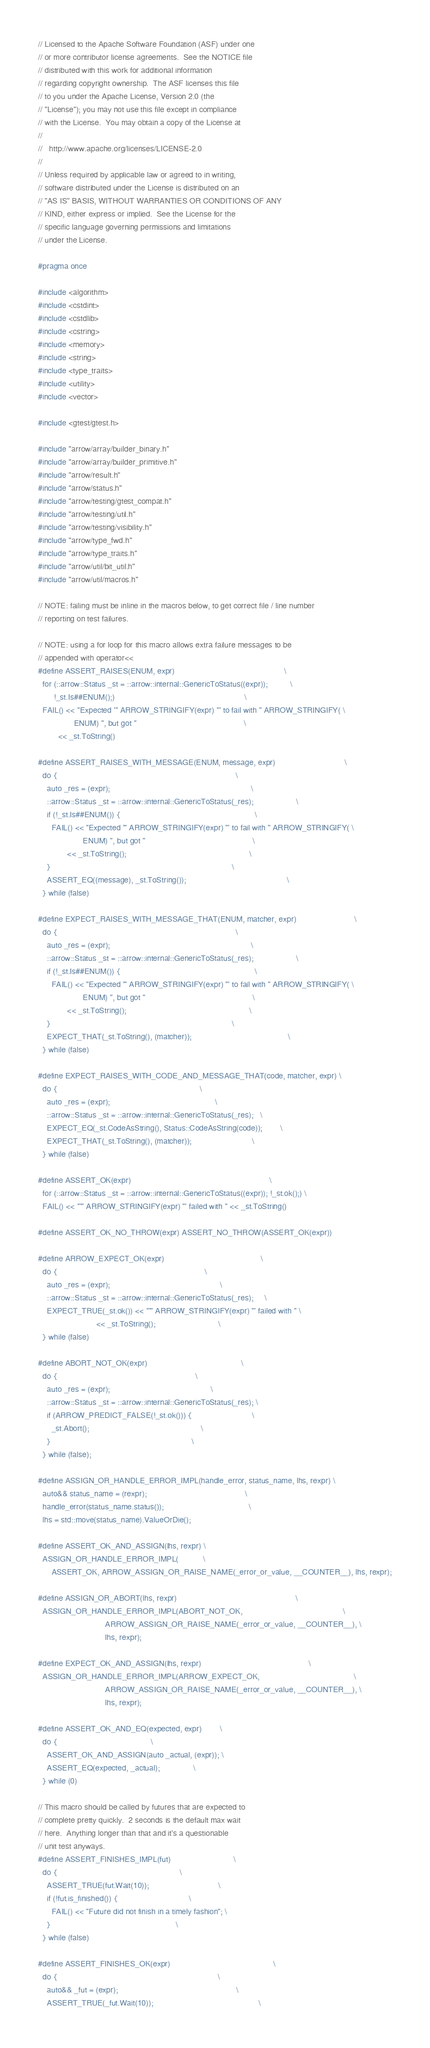<code> <loc_0><loc_0><loc_500><loc_500><_C_>// Licensed to the Apache Software Foundation (ASF) under one
// or more contributor license agreements.  See the NOTICE file
// distributed with this work for additional information
// regarding copyright ownership.  The ASF licenses this file
// to you under the Apache License, Version 2.0 (the
// "License"); you may not use this file except in compliance
// with the License.  You may obtain a copy of the License at
//
//   http://www.apache.org/licenses/LICENSE-2.0
//
// Unless required by applicable law or agreed to in writing,
// software distributed under the License is distributed on an
// "AS IS" BASIS, WITHOUT WARRANTIES OR CONDITIONS OF ANY
// KIND, either express or implied.  See the License for the
// specific language governing permissions and limitations
// under the License.

#pragma once

#include <algorithm>
#include <cstdint>
#include <cstdlib>
#include <cstring>
#include <memory>
#include <string>
#include <type_traits>
#include <utility>
#include <vector>

#include <gtest/gtest.h>

#include "arrow/array/builder_binary.h"
#include "arrow/array/builder_primitive.h"
#include "arrow/result.h"
#include "arrow/status.h"
#include "arrow/testing/gtest_compat.h"
#include "arrow/testing/util.h"
#include "arrow/testing/visibility.h"
#include "arrow/type_fwd.h"
#include "arrow/type_traits.h"
#include "arrow/util/bit_util.h"
#include "arrow/util/macros.h"

// NOTE: failing must be inline in the macros below, to get correct file / line number
// reporting on test failures.

// NOTE: using a for loop for this macro allows extra failure messages to be
// appended with operator<<
#define ASSERT_RAISES(ENUM, expr)                                                 \
  for (::arrow::Status _st = ::arrow::internal::GenericToStatus((expr));          \
       !_st.Is##ENUM();)                                                          \
  FAIL() << "Expected '" ARROW_STRINGIFY(expr) "' to fail with " ARROW_STRINGIFY( \
                ENUM) ", but got "                                                \
         << _st.ToString()

#define ASSERT_RAISES_WITH_MESSAGE(ENUM, message, expr)                               \
  do {                                                                                \
    auto _res = (expr);                                                               \
    ::arrow::Status _st = ::arrow::internal::GenericToStatus(_res);                   \
    if (!_st.Is##ENUM()) {                                                            \
      FAIL() << "Expected '" ARROW_STRINGIFY(expr) "' to fail with " ARROW_STRINGIFY( \
                    ENUM) ", but got "                                                \
             << _st.ToString();                                                       \
    }                                                                                 \
    ASSERT_EQ((message), _st.ToString());                                             \
  } while (false)

#define EXPECT_RAISES_WITH_MESSAGE_THAT(ENUM, matcher, expr)                          \
  do {                                                                                \
    auto _res = (expr);                                                               \
    ::arrow::Status _st = ::arrow::internal::GenericToStatus(_res);                   \
    if (!_st.Is##ENUM()) {                                                            \
      FAIL() << "Expected '" ARROW_STRINGIFY(expr) "' to fail with " ARROW_STRINGIFY( \
                    ENUM) ", but got "                                                \
             << _st.ToString();                                                       \
    }                                                                                 \
    EXPECT_THAT(_st.ToString(), (matcher));                                           \
  } while (false)

#define EXPECT_RAISES_WITH_CODE_AND_MESSAGE_THAT(code, matcher, expr) \
  do {                                                                \
    auto _res = (expr);                                               \
    ::arrow::Status _st = ::arrow::internal::GenericToStatus(_res);   \
    EXPECT_EQ(_st.CodeAsString(), Status::CodeAsString(code));        \
    EXPECT_THAT(_st.ToString(), (matcher));                           \
  } while (false)

#define ASSERT_OK(expr)                                                              \
  for (::arrow::Status _st = ::arrow::internal::GenericToStatus((expr)); !_st.ok();) \
  FAIL() << "'" ARROW_STRINGIFY(expr) "' failed with " << _st.ToString()

#define ASSERT_OK_NO_THROW(expr) ASSERT_NO_THROW(ASSERT_OK(expr))

#define ARROW_EXPECT_OK(expr)                                           \
  do {                                                                  \
    auto _res = (expr);                                                 \
    ::arrow::Status _st = ::arrow::internal::GenericToStatus(_res);     \
    EXPECT_TRUE(_st.ok()) << "'" ARROW_STRINGIFY(expr) "' failed with " \
                          << _st.ToString();                            \
  } while (false)

#define ABORT_NOT_OK(expr)                                          \
  do {                                                              \
    auto _res = (expr);                                             \
    ::arrow::Status _st = ::arrow::internal::GenericToStatus(_res); \
    if (ARROW_PREDICT_FALSE(!_st.ok())) {                           \
      _st.Abort();                                                  \
    }                                                               \
  } while (false);

#define ASSIGN_OR_HANDLE_ERROR_IMPL(handle_error, status_name, lhs, rexpr) \
  auto&& status_name = (rexpr);                                            \
  handle_error(status_name.status());                                      \
  lhs = std::move(status_name).ValueOrDie();

#define ASSERT_OK_AND_ASSIGN(lhs, rexpr) \
  ASSIGN_OR_HANDLE_ERROR_IMPL(           \
      ASSERT_OK, ARROW_ASSIGN_OR_RAISE_NAME(_error_or_value, __COUNTER__), lhs, rexpr);

#define ASSIGN_OR_ABORT(lhs, rexpr)                                                     \
  ASSIGN_OR_HANDLE_ERROR_IMPL(ABORT_NOT_OK,                                             \
                              ARROW_ASSIGN_OR_RAISE_NAME(_error_or_value, __COUNTER__), \
                              lhs, rexpr);

#define EXPECT_OK_AND_ASSIGN(lhs, rexpr)                                                \
  ASSIGN_OR_HANDLE_ERROR_IMPL(ARROW_EXPECT_OK,                                          \
                              ARROW_ASSIGN_OR_RAISE_NAME(_error_or_value, __COUNTER__), \
                              lhs, rexpr);

#define ASSERT_OK_AND_EQ(expected, expr)        \
  do {                                          \
    ASSERT_OK_AND_ASSIGN(auto _actual, (expr)); \
    ASSERT_EQ(expected, _actual);               \
  } while (0)

// This macro should be called by futures that are expected to
// complete pretty quickly.  2 seconds is the default max wait
// here.  Anything longer than that and it's a questionable
// unit test anyways.
#define ASSERT_FINISHES_IMPL(fut)                            \
  do {                                                       \
    ASSERT_TRUE(fut.Wait(10));                               \
    if (!fut.is_finished()) {                                \
      FAIL() << "Future did not finish in a timely fashion"; \
    }                                                        \
  } while (false)

#define ASSERT_FINISHES_OK(expr)                                              \
  do {                                                                        \
    auto&& _fut = (expr);                                                     \
    ASSERT_TRUE(_fut.Wait(10));                                               \</code> 